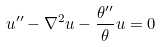Convert formula to latex. <formula><loc_0><loc_0><loc_500><loc_500>u ^ { \prime \prime } - \nabla ^ { 2 } u - \frac { \theta ^ { \prime \prime } } { \theta } u = 0</formula> 